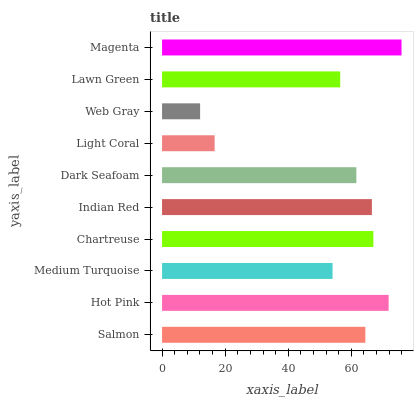Is Web Gray the minimum?
Answer yes or no. Yes. Is Magenta the maximum?
Answer yes or no. Yes. Is Hot Pink the minimum?
Answer yes or no. No. Is Hot Pink the maximum?
Answer yes or no. No. Is Hot Pink greater than Salmon?
Answer yes or no. Yes. Is Salmon less than Hot Pink?
Answer yes or no. Yes. Is Salmon greater than Hot Pink?
Answer yes or no. No. Is Hot Pink less than Salmon?
Answer yes or no. No. Is Salmon the high median?
Answer yes or no. Yes. Is Dark Seafoam the low median?
Answer yes or no. Yes. Is Dark Seafoam the high median?
Answer yes or no. No. Is Lawn Green the low median?
Answer yes or no. No. 